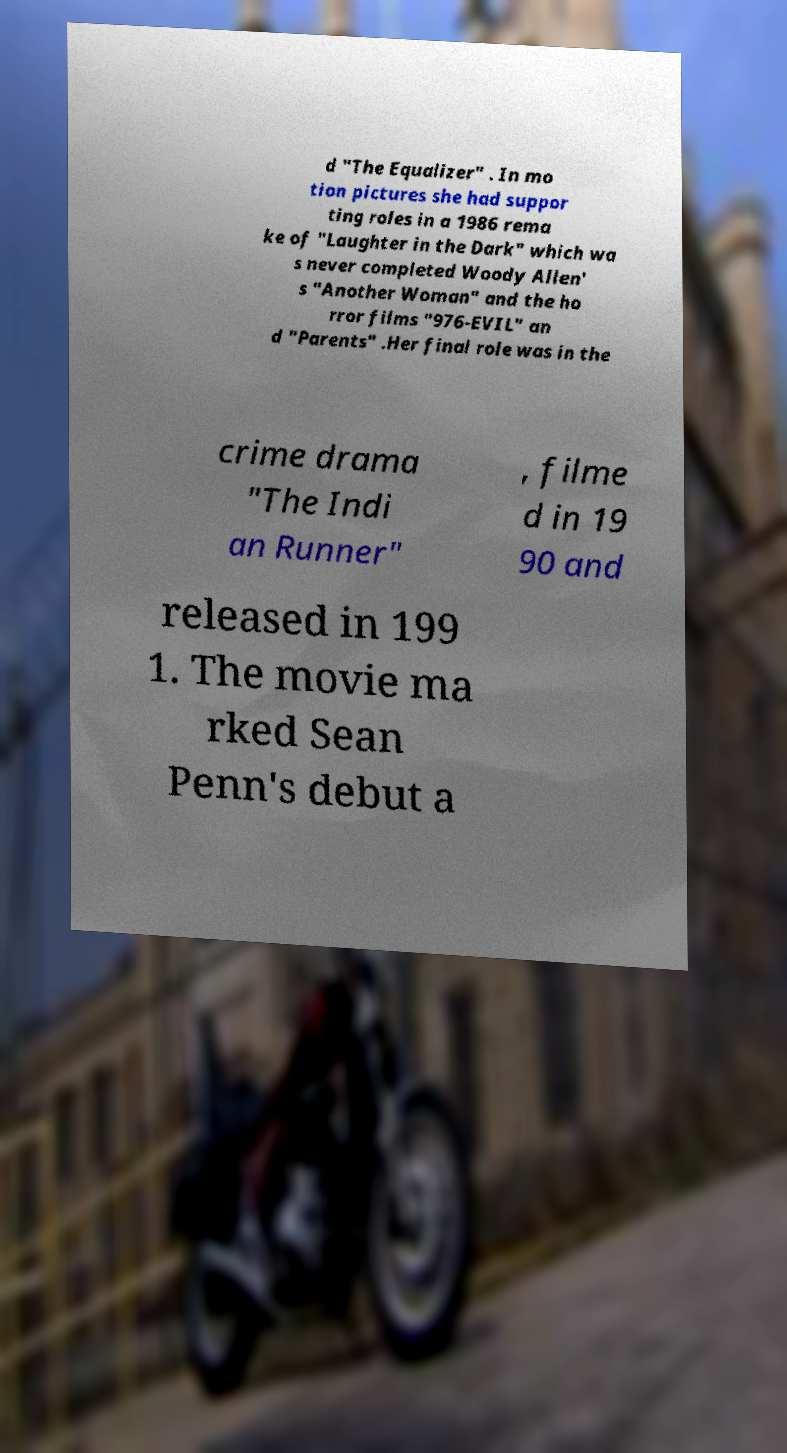Could you extract and type out the text from this image? d "The Equalizer" . In mo tion pictures she had suppor ting roles in a 1986 rema ke of "Laughter in the Dark" which wa s never completed Woody Allen' s "Another Woman" and the ho rror films "976-EVIL" an d "Parents" .Her final role was in the crime drama "The Indi an Runner" , filme d in 19 90 and released in 199 1. The movie ma rked Sean Penn's debut a 